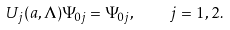<formula> <loc_0><loc_0><loc_500><loc_500>U _ { j } ( a , \Lambda ) \Psi _ { 0 j } = \Psi _ { 0 j } , \quad j = 1 , 2 .</formula> 